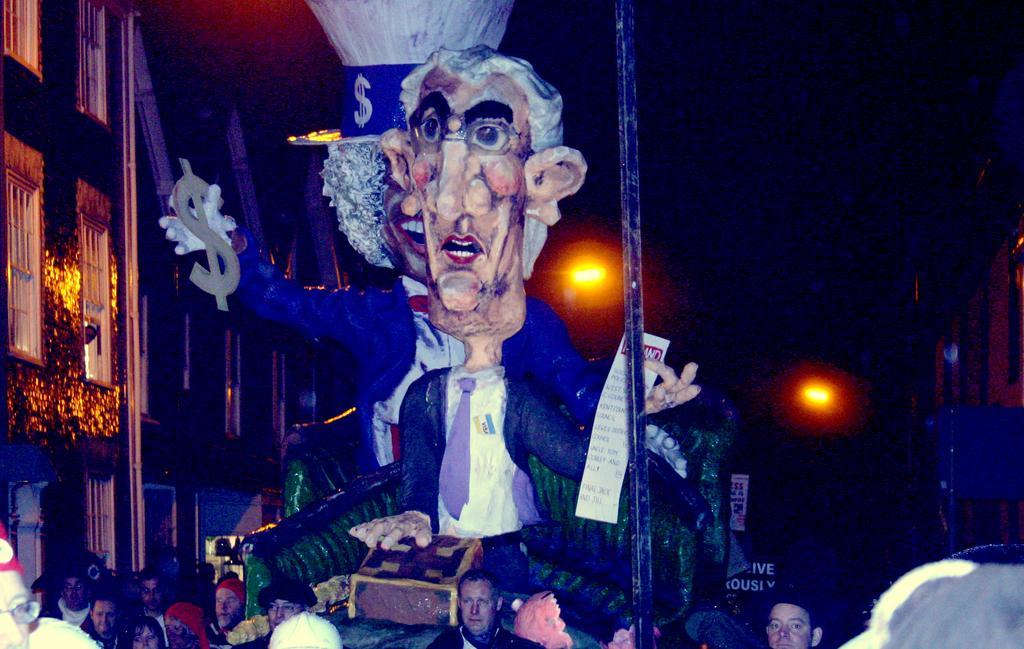How would you summarize this image in a sentence or two? In this image in the front there are persons and there is a pole which is black in colour. In the center there is a statue. On the left side there are buildings. In the background there are lights. 